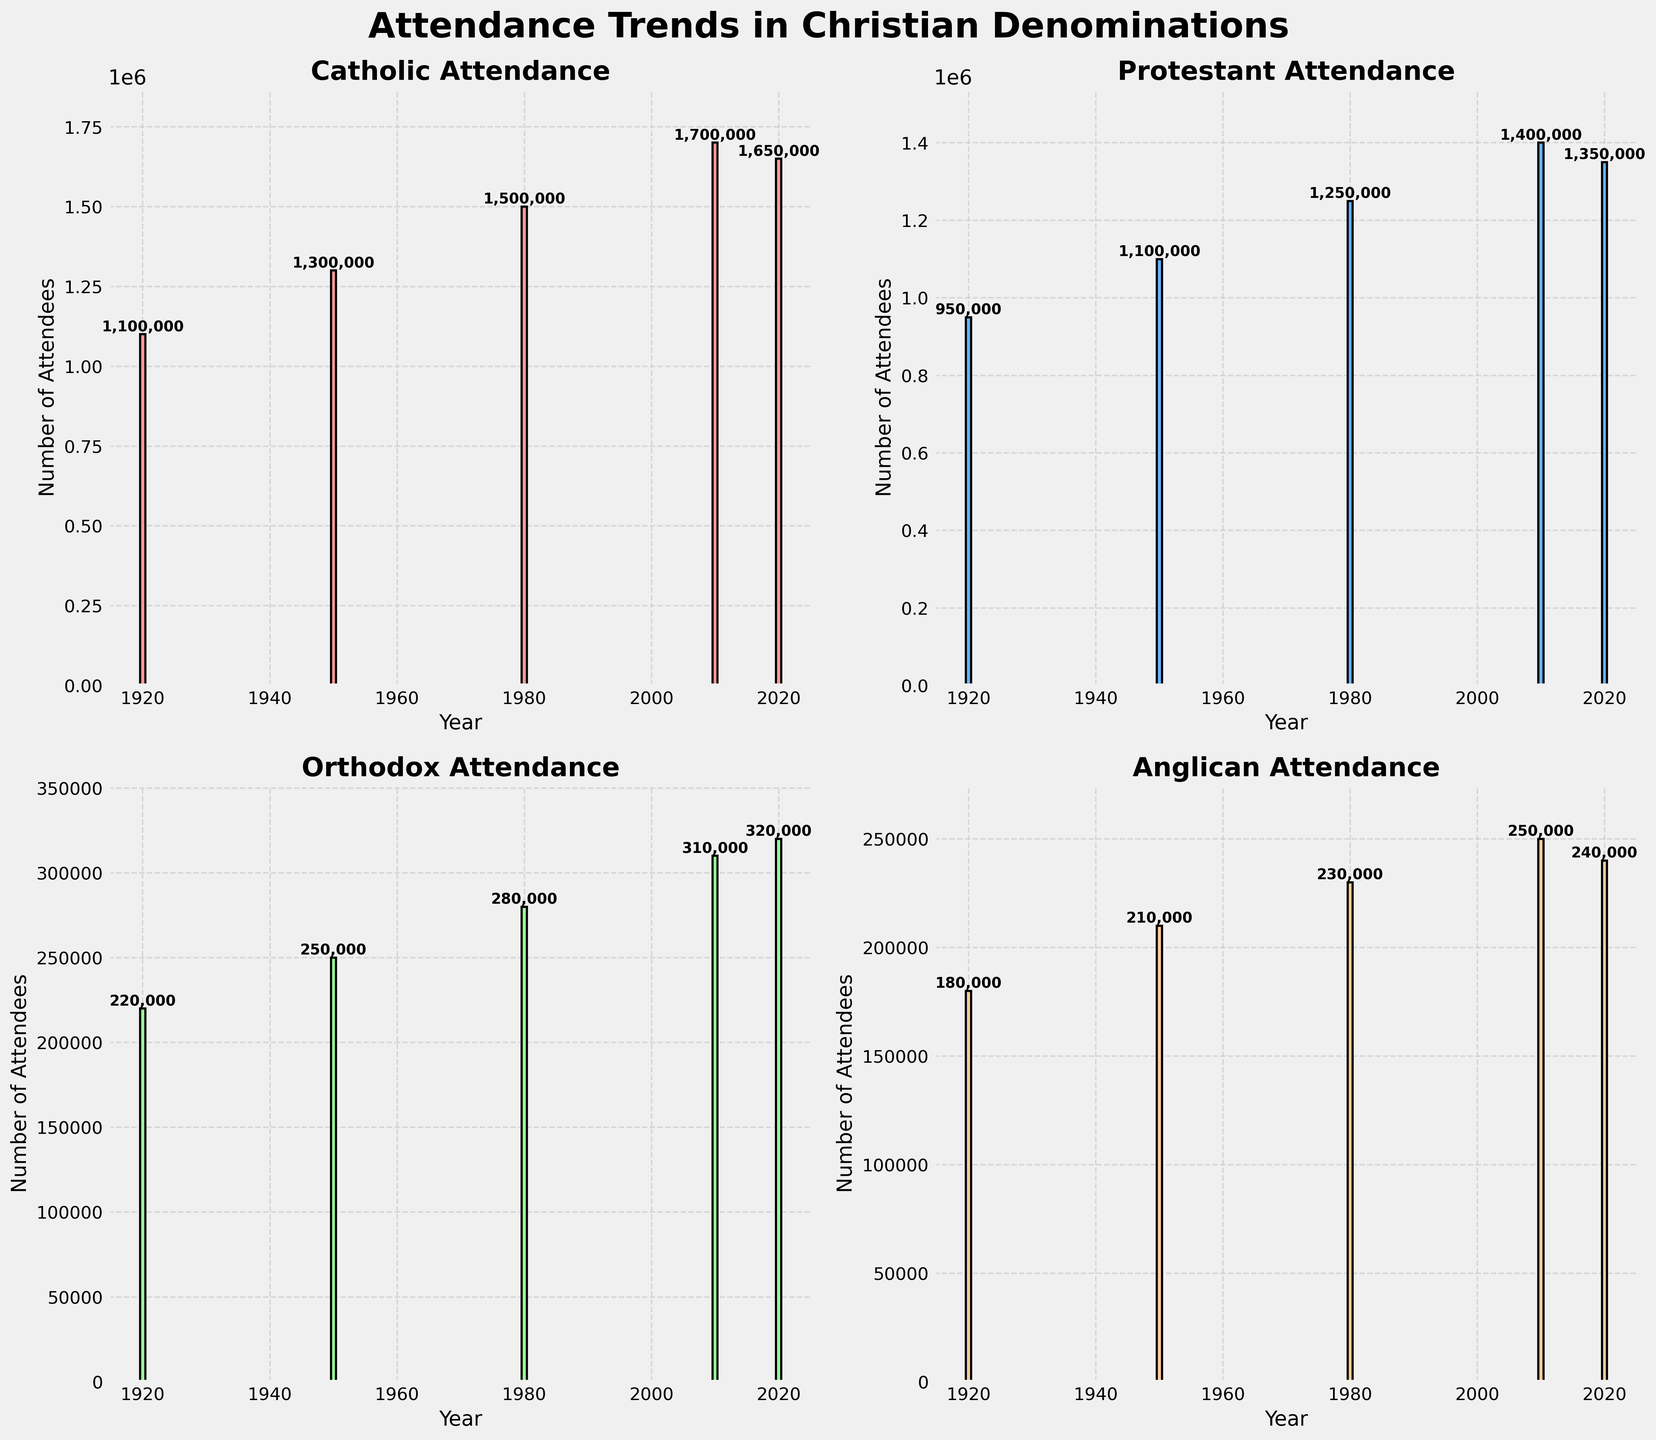What is the title of the figure? The title is at the top center of the figure and generally set in a larger and bolder font. Here, it reads "Attendance Trends in Christian Denominations."
Answer: Attendance Trends in Christian Denominations Which denomination had the highest attendance in 2020? Looking at the bar heights for the year 2020 across all subplots, the Catholic denomination has the tallest bar for that year, indicating the highest attendance.
Answer: Catholic How has Anglican attendance changed from 1920 to 2020? Observing the height of the bars in the Anglican subplot, we see that it increased from 180,000 in 1920 to 240,000 in 2020.
Answer: Increased What is the average attendance of the Protestant denomination across all years shown? To calculate the average, we add up the attendance numbers for each year (950,000 + 1,100,000 + 1,250,000 + 1,400,000 + 1,350,000) and divide by the number of years (5). This gives us (950,000 + 1,100,000 + 1,250,000 + 1,400,000 + 1,350,000) / 5 = 6,050,000 / 5 = 1,210,000.
Answer: 1,210,000 By how much did the Catholic attendance increase from 1920 to 2010? To find the difference, we subtract the 1920 attendance from the 2010 attendance for the Catholic denomination: 1,700,000 - 1,100,000 = 600,000.
Answer: 600,000 In which year did Orthodox attendance see the highest growth compared to the previous data point? Calculate the change in attendance between consecutive years for the Orthodox denomination:  
1950-1920: 250,000 - 220,000 = 30,000  
1980-1950: 280,000 - 250,000 = 30,000  
2010-1980: 310,000 - 280,000 = 30,000  
2020-2010: 320,000 - 310,000 = 10,000.  
The highest growth (30,000) is observed in the years 1950, 1980, and 2010.
Answer: 1950, 1980, 2010 Which denomination showed a decline in attendance from 2010 to 2020? Comparing the bar heights for the years 2010 and 2020 in each subplot, it is seen that the Catholic and Anglican denominations both had declines: Catholic (from 1,700,000 to 1,650,000) and Anglican (from 250,000 to 240,000).
Answer: Catholic and Anglican How much lower was Anglican attendance in 1920 compared to the Orthodox attendance in the same year? Subtract the attendance numbers for Anglican and Orthodox in 1920: 220,000 - 180,000 = 40,000.
Answer: 40,000 